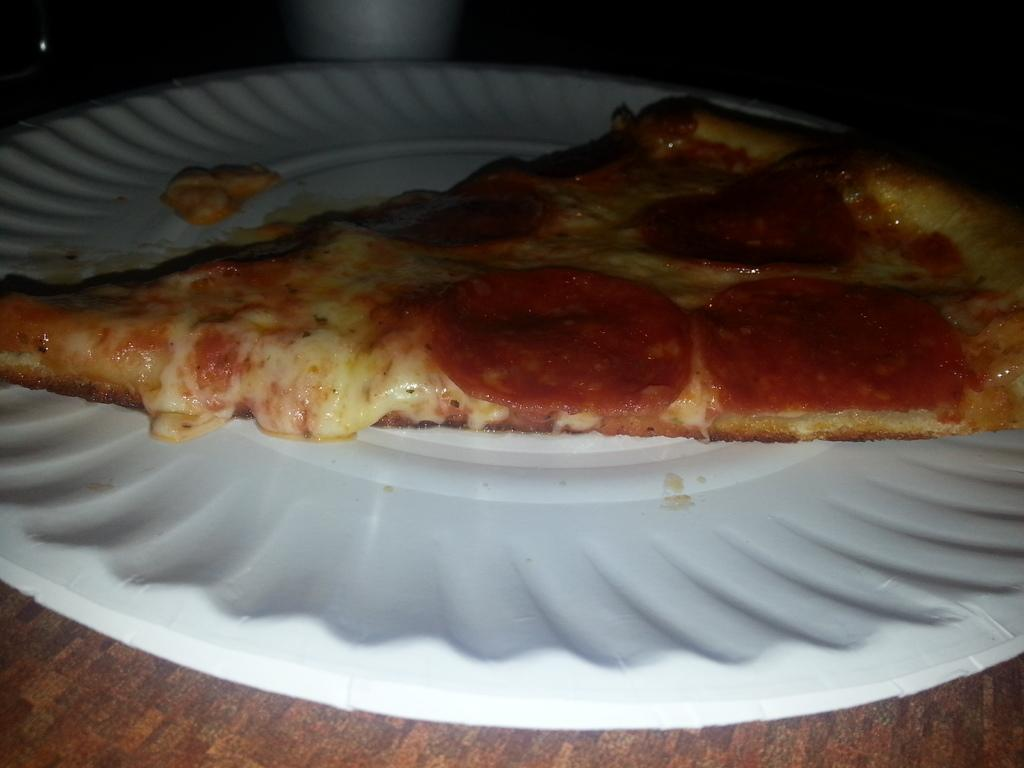What is on the plate that is visible in the image? There is a plate with food items in the image. Can you describe the white-colored object at the top of the image? Unfortunately, the facts provided do not give enough information to describe the white-colored object at the top of the image. How many friends are sitting on the corn in the image? There is no corn or friends present in the image. 